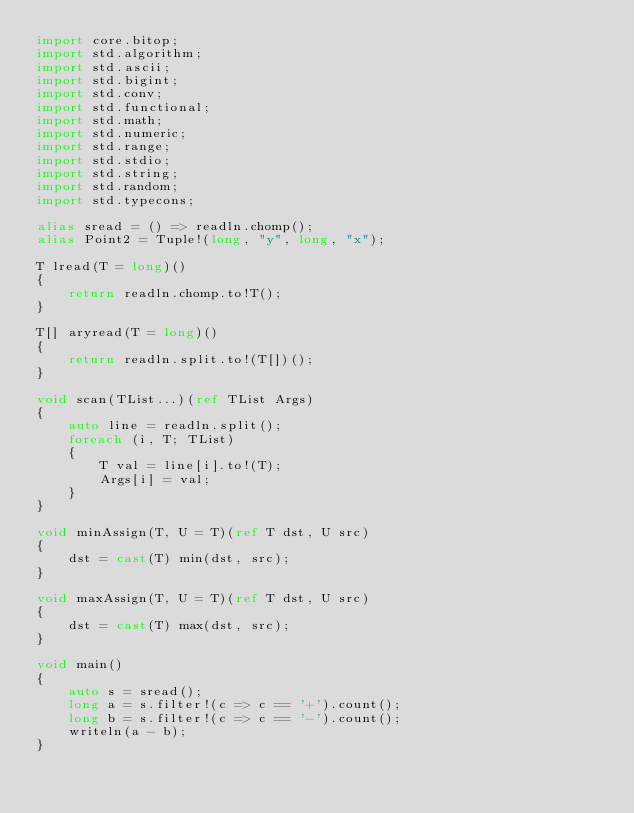Convert code to text. <code><loc_0><loc_0><loc_500><loc_500><_D_>import core.bitop;
import std.algorithm;
import std.ascii;
import std.bigint;
import std.conv;
import std.functional;
import std.math;
import std.numeric;
import std.range;
import std.stdio;
import std.string;
import std.random;
import std.typecons;

alias sread = () => readln.chomp();
alias Point2 = Tuple!(long, "y", long, "x");

T lread(T = long)()
{
    return readln.chomp.to!T();
}

T[] aryread(T = long)()
{
    return readln.split.to!(T[])();
}

void scan(TList...)(ref TList Args)
{
    auto line = readln.split();
    foreach (i, T; TList)
    {
        T val = line[i].to!(T);
        Args[i] = val;
    }
}

void minAssign(T, U = T)(ref T dst, U src)
{
    dst = cast(T) min(dst, src);
}

void maxAssign(T, U = T)(ref T dst, U src)
{
    dst = cast(T) max(dst, src);
}

void main()
{
    auto s = sread();
    long a = s.filter!(c => c == '+').count();
    long b = s.filter!(c => c == '-').count();
    writeln(a - b);
}
</code> 